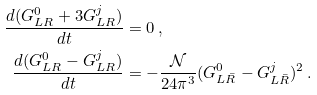<formula> <loc_0><loc_0><loc_500><loc_500>\frac { d ( G _ { L R } ^ { 0 } + 3 G _ { L R } ^ { j } ) } { d t } & = 0 \, , \\ \frac { d ( G _ { L R } ^ { 0 } - G _ { L R } ^ { j } ) } { d t } & = - \frac { \mathcal { N } } { 2 4 \pi ^ { 3 } } ( G _ { L \bar { R } } ^ { 0 } - G _ { L \bar { R } } ^ { j } ) ^ { 2 } \, .</formula> 